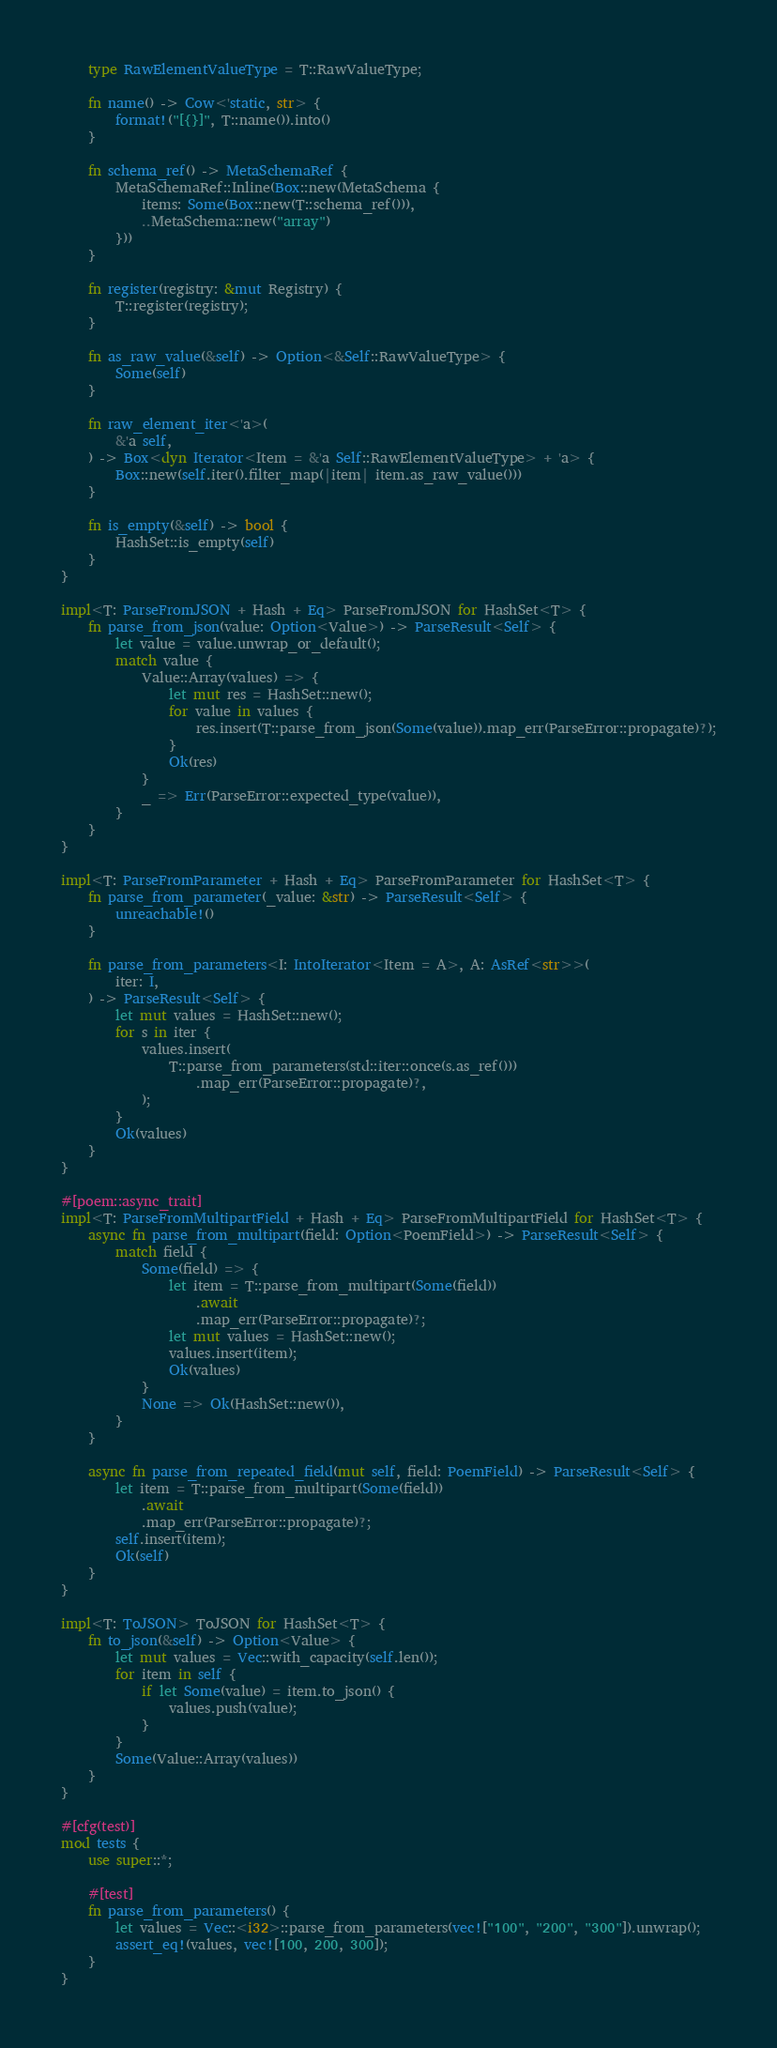Convert code to text. <code><loc_0><loc_0><loc_500><loc_500><_Rust_>    type RawElementValueType = T::RawValueType;

    fn name() -> Cow<'static, str> {
        format!("[{}]", T::name()).into()
    }

    fn schema_ref() -> MetaSchemaRef {
        MetaSchemaRef::Inline(Box::new(MetaSchema {
            items: Some(Box::new(T::schema_ref())),
            ..MetaSchema::new("array")
        }))
    }

    fn register(registry: &mut Registry) {
        T::register(registry);
    }

    fn as_raw_value(&self) -> Option<&Self::RawValueType> {
        Some(self)
    }

    fn raw_element_iter<'a>(
        &'a self,
    ) -> Box<dyn Iterator<Item = &'a Self::RawElementValueType> + 'a> {
        Box::new(self.iter().filter_map(|item| item.as_raw_value()))
    }

    fn is_empty(&self) -> bool {
        HashSet::is_empty(self)
    }
}

impl<T: ParseFromJSON + Hash + Eq> ParseFromJSON for HashSet<T> {
    fn parse_from_json(value: Option<Value>) -> ParseResult<Self> {
        let value = value.unwrap_or_default();
        match value {
            Value::Array(values) => {
                let mut res = HashSet::new();
                for value in values {
                    res.insert(T::parse_from_json(Some(value)).map_err(ParseError::propagate)?);
                }
                Ok(res)
            }
            _ => Err(ParseError::expected_type(value)),
        }
    }
}

impl<T: ParseFromParameter + Hash + Eq> ParseFromParameter for HashSet<T> {
    fn parse_from_parameter(_value: &str) -> ParseResult<Self> {
        unreachable!()
    }

    fn parse_from_parameters<I: IntoIterator<Item = A>, A: AsRef<str>>(
        iter: I,
    ) -> ParseResult<Self> {
        let mut values = HashSet::new();
        for s in iter {
            values.insert(
                T::parse_from_parameters(std::iter::once(s.as_ref()))
                    .map_err(ParseError::propagate)?,
            );
        }
        Ok(values)
    }
}

#[poem::async_trait]
impl<T: ParseFromMultipartField + Hash + Eq> ParseFromMultipartField for HashSet<T> {
    async fn parse_from_multipart(field: Option<PoemField>) -> ParseResult<Self> {
        match field {
            Some(field) => {
                let item = T::parse_from_multipart(Some(field))
                    .await
                    .map_err(ParseError::propagate)?;
                let mut values = HashSet::new();
                values.insert(item);
                Ok(values)
            }
            None => Ok(HashSet::new()),
        }
    }

    async fn parse_from_repeated_field(mut self, field: PoemField) -> ParseResult<Self> {
        let item = T::parse_from_multipart(Some(field))
            .await
            .map_err(ParseError::propagate)?;
        self.insert(item);
        Ok(self)
    }
}

impl<T: ToJSON> ToJSON for HashSet<T> {
    fn to_json(&self) -> Option<Value> {
        let mut values = Vec::with_capacity(self.len());
        for item in self {
            if let Some(value) = item.to_json() {
                values.push(value);
            }
        }
        Some(Value::Array(values))
    }
}

#[cfg(test)]
mod tests {
    use super::*;

    #[test]
    fn parse_from_parameters() {
        let values = Vec::<i32>::parse_from_parameters(vec!["100", "200", "300"]).unwrap();
        assert_eq!(values, vec![100, 200, 300]);
    }
}
</code> 